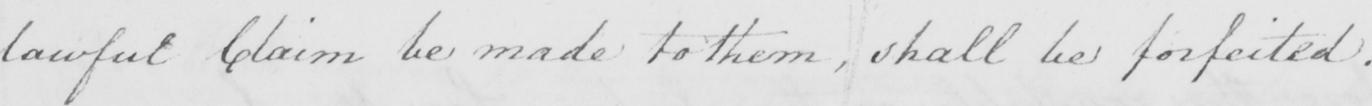Please transcribe the handwritten text in this image. lawful Claim be made to them , shall be forfeited . 